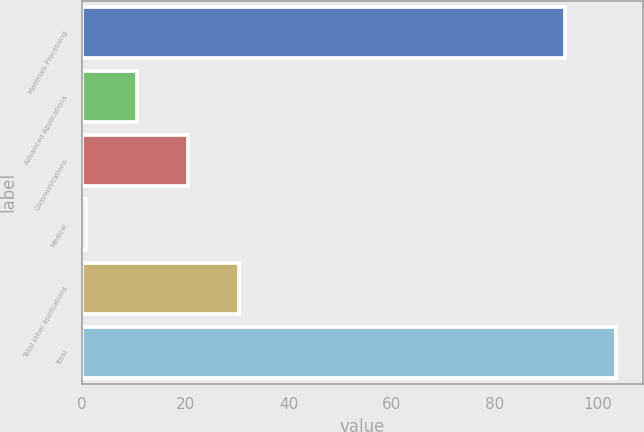Convert chart to OTSL. <chart><loc_0><loc_0><loc_500><loc_500><bar_chart><fcel>Materials Processing<fcel>Advanced Applications<fcel>Communications<fcel>Medical<fcel>Total other applications<fcel>Total<nl><fcel>93.6<fcel>10.63<fcel>20.56<fcel>0.7<fcel>30.49<fcel>103.53<nl></chart> 